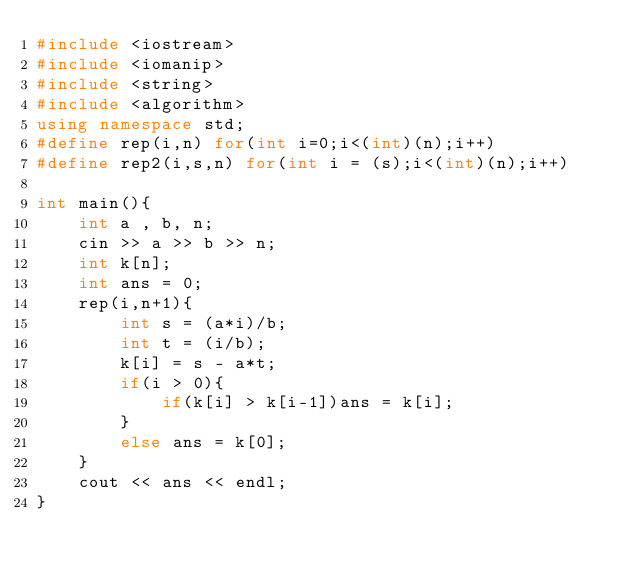<code> <loc_0><loc_0><loc_500><loc_500><_C++_>#include <iostream>
#include <iomanip>
#include <string>
#include <algorithm>
using namespace std;
#define rep(i,n) for(int i=0;i<(int)(n);i++)
#define rep2(i,s,n) for(int i = (s);i<(int)(n);i++)

int main(){
    int a , b, n;
    cin >> a >> b >> n;
    int k[n];
    int ans = 0;
    rep(i,n+1){
        int s = (a*i)/b;
        int t = (i/b);
        k[i] = s - a*t;
        if(i > 0){
            if(k[i] > k[i-1])ans = k[i];
        }
        else ans = k[0];
    }
    cout << ans << endl;
}</code> 